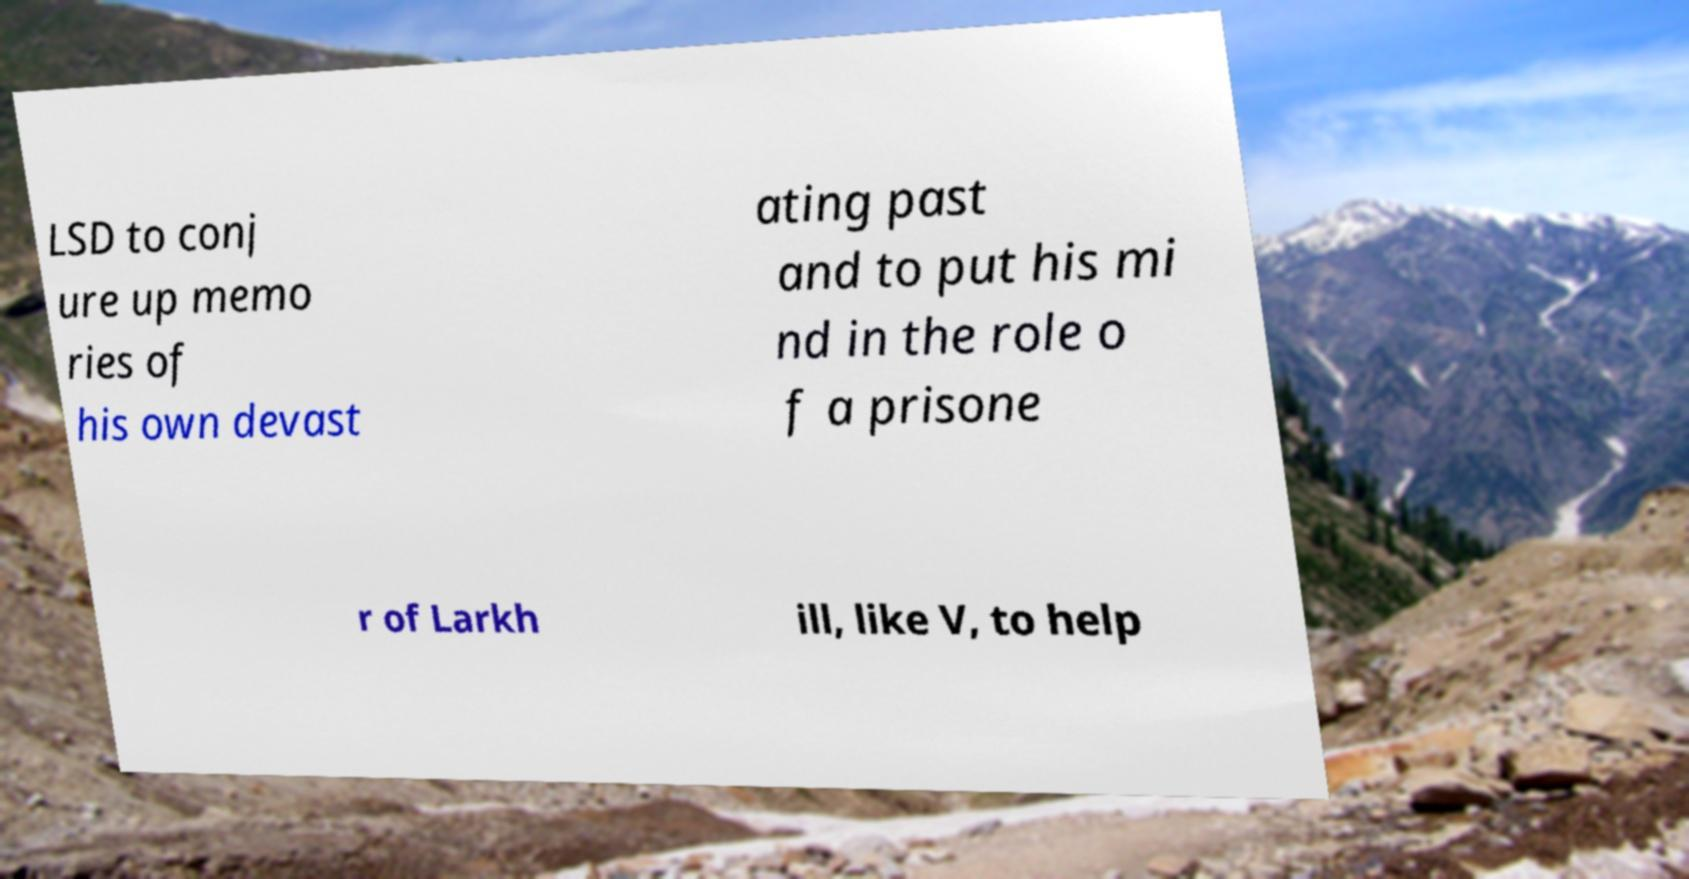For documentation purposes, I need the text within this image transcribed. Could you provide that? LSD to conj ure up memo ries of his own devast ating past and to put his mi nd in the role o f a prisone r of Larkh ill, like V, to help 